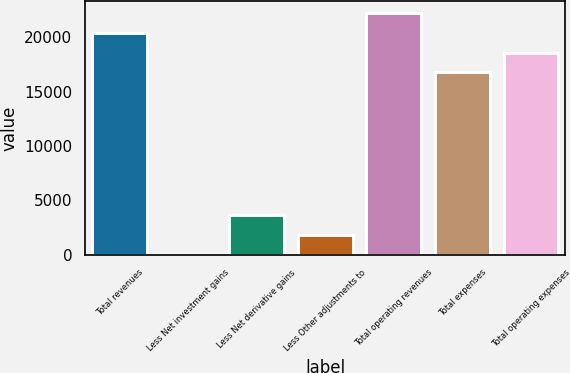Convert chart. <chart><loc_0><loc_0><loc_500><loc_500><bar_chart><fcel>Total revenues<fcel>Less Net investment gains<fcel>Less Net derivative gains<fcel>Less Other adjustments to<fcel>Total operating revenues<fcel>Total expenses<fcel>Total operating expenses<nl><fcel>20394.6<fcel>21<fcel>3654.6<fcel>1837.8<fcel>22211.4<fcel>16761<fcel>18577.8<nl></chart> 